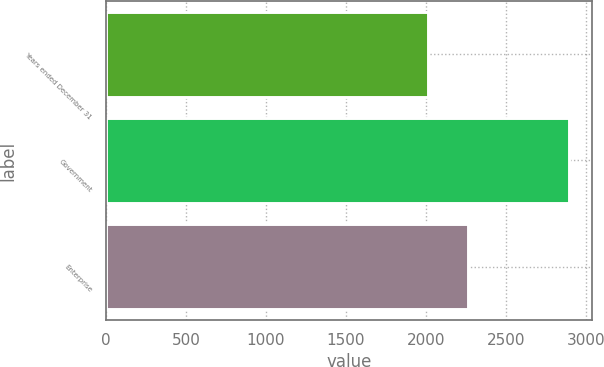Convert chart. <chart><loc_0><loc_0><loc_500><loc_500><bar_chart><fcel>Years ended December 31<fcel>Government<fcel>Enterprise<nl><fcel>2011<fcel>2892<fcel>2264<nl></chart> 